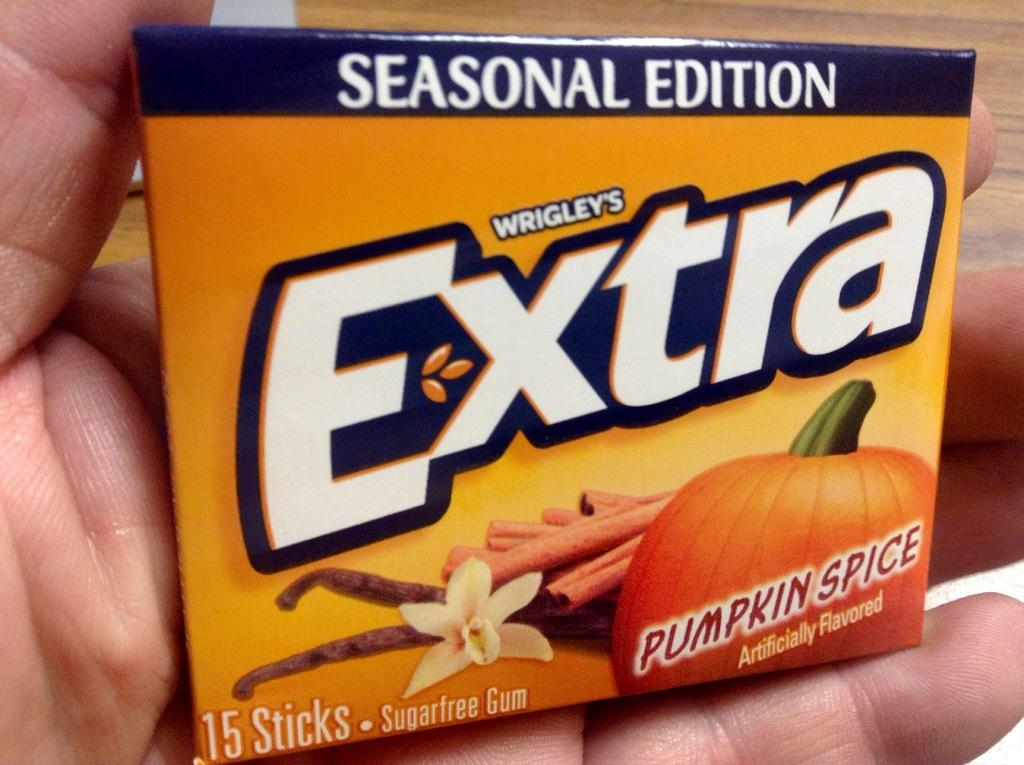<image>
Relay a brief, clear account of the picture shown. Advertisement for Wrigley's pumpkin spiced Extra chewing gum. 